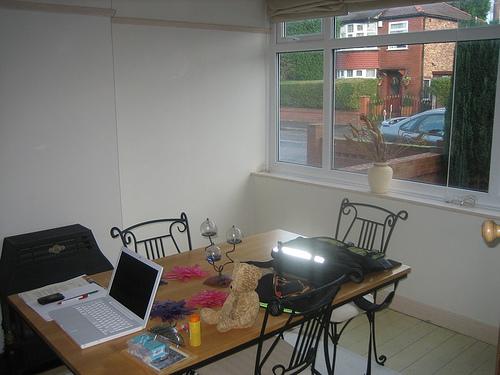How many teapots are in the shelves?
Short answer required. 0. What color is the laptop?
Short answer required. White. How many chairs are in the photo?
Quick response, please. 3. How many laptop computers are visible in this image?
Short answer required. 1. Is the laptop on a desk?
Quick response, please. Yes. Is there a mouse on the desk?
Give a very brief answer. No. 